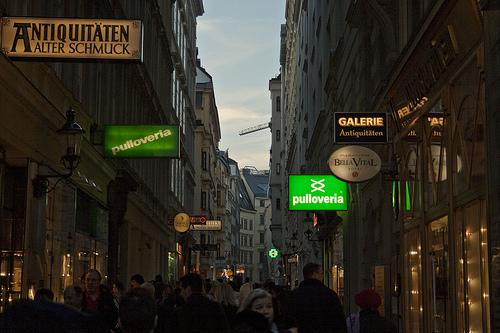Question: when do people throng in the area?
Choices:
A. Before noon.
B. After midnight.
C. After office hours.
D. At sunrise.
Answer with the letter. Answer: C Question: what place is that?
Choices:
A. A private lot.
B. A store.
C. A public place.
D. A barn.
Answer with the letter. Answer: C Question: where can you shop?
Choices:
A. On the internet.
B. In the store in the picture.
C. At a mall.
D. From a street stall.
Answer with the letter. Answer: B Question: what are the people wearing?
Choices:
A. They are all wearing bathing suits.
B. They are all wearing turbans.
C. They are all wearing jeans.
D. They are all wearing suits.
Answer with the letter. Answer: D Question: who can you see in the picture?
Choices:
A. People eating at a table.
B. People walking on the street.
C. People flying kites.
D. People driving cars.
Answer with the letter. Answer: B 